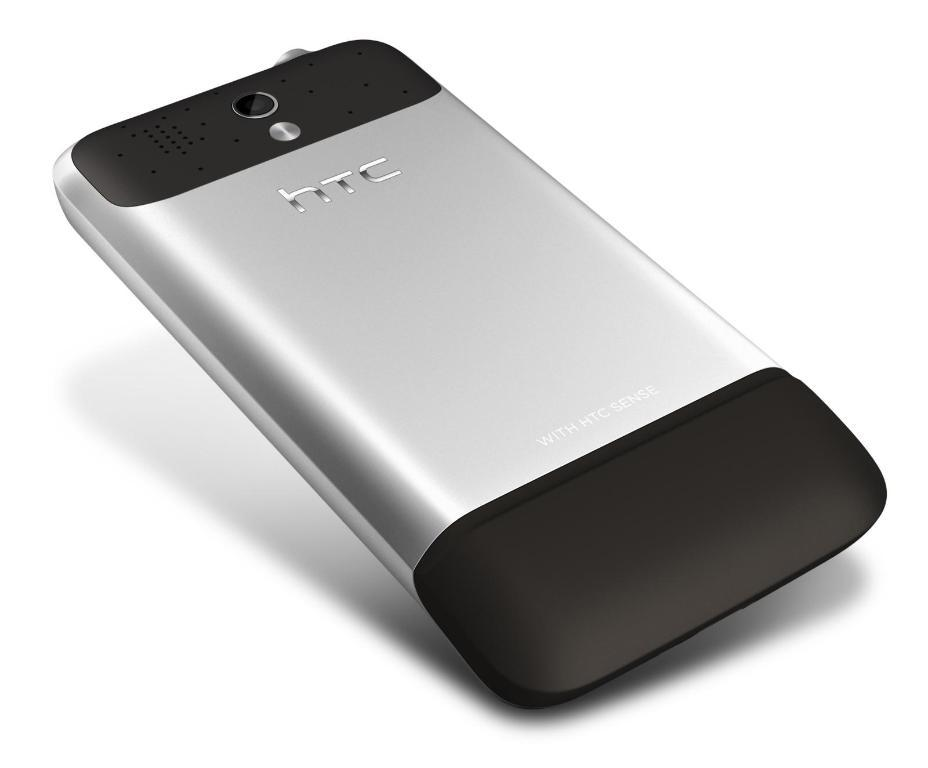<image>
Render a clear and concise summary of the photo. A silver and black htc phone against a white back drop. 